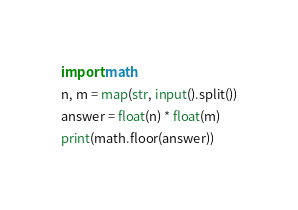Convert code to text. <code><loc_0><loc_0><loc_500><loc_500><_Python_>import math
n, m = map(str, input().split())
answer = float(n) * float(m)
print(math.floor(answer))</code> 